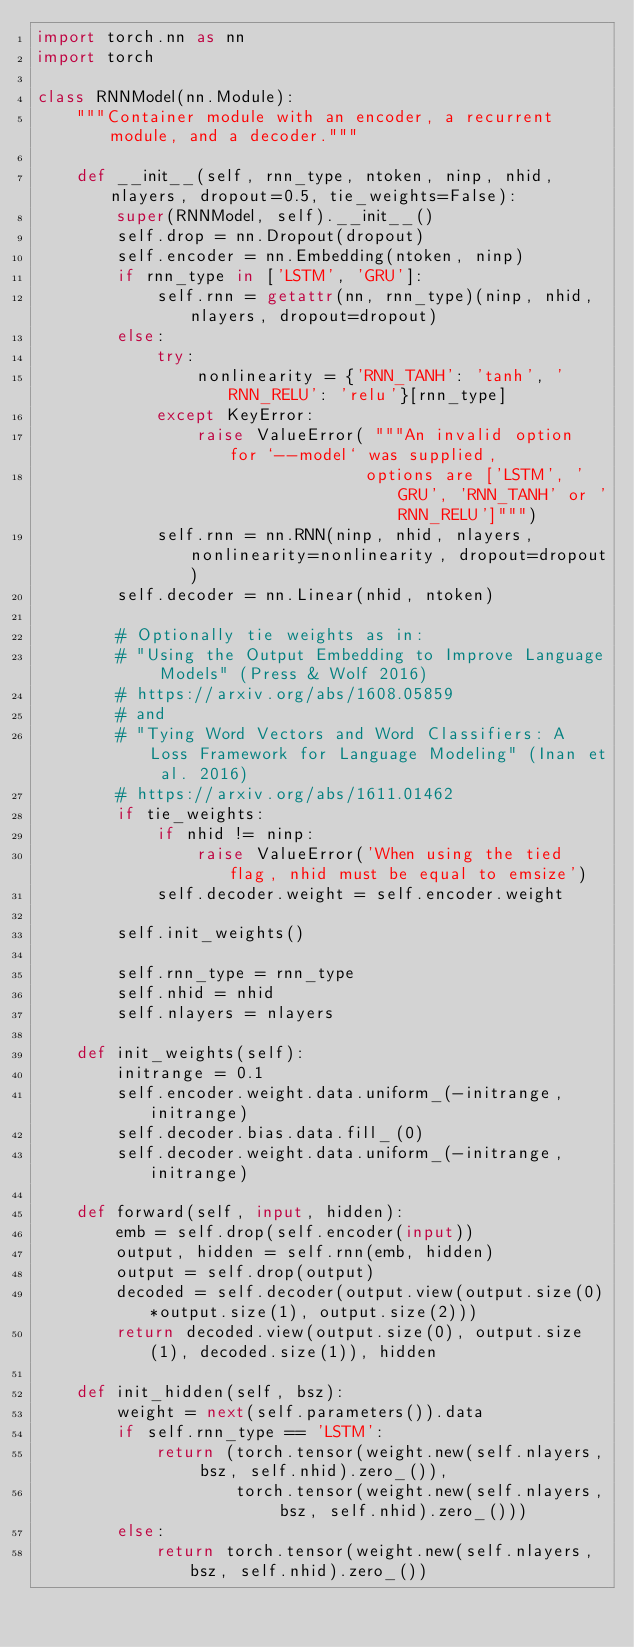Convert code to text. <code><loc_0><loc_0><loc_500><loc_500><_Python_>import torch.nn as nn
import torch

class RNNModel(nn.Module):
    """Container module with an encoder, a recurrent module, and a decoder."""

    def __init__(self, rnn_type, ntoken, ninp, nhid, nlayers, dropout=0.5, tie_weights=False):
        super(RNNModel, self).__init__()
        self.drop = nn.Dropout(dropout)
        self.encoder = nn.Embedding(ntoken, ninp)
        if rnn_type in ['LSTM', 'GRU']:
            self.rnn = getattr(nn, rnn_type)(ninp, nhid, nlayers, dropout=dropout)
        else:
            try:
                nonlinearity = {'RNN_TANH': 'tanh', 'RNN_RELU': 'relu'}[rnn_type]
            except KeyError:
                raise ValueError( """An invalid option for `--model` was supplied,
                                 options are ['LSTM', 'GRU', 'RNN_TANH' or 'RNN_RELU']""")
            self.rnn = nn.RNN(ninp, nhid, nlayers, nonlinearity=nonlinearity, dropout=dropout)
        self.decoder = nn.Linear(nhid, ntoken)

        # Optionally tie weights as in:
        # "Using the Output Embedding to Improve Language Models" (Press & Wolf 2016)
        # https://arxiv.org/abs/1608.05859
        # and
        # "Tying Word Vectors and Word Classifiers: A Loss Framework for Language Modeling" (Inan et al. 2016)
        # https://arxiv.org/abs/1611.01462
        if tie_weights:
            if nhid != ninp:
                raise ValueError('When using the tied flag, nhid must be equal to emsize')
            self.decoder.weight = self.encoder.weight

        self.init_weights()

        self.rnn_type = rnn_type
        self.nhid = nhid
        self.nlayers = nlayers

    def init_weights(self):
        initrange = 0.1
        self.encoder.weight.data.uniform_(-initrange, initrange)
        self.decoder.bias.data.fill_(0)
        self.decoder.weight.data.uniform_(-initrange, initrange)

    def forward(self, input, hidden):
        emb = self.drop(self.encoder(input))
        output, hidden = self.rnn(emb, hidden)
        output = self.drop(output)
        decoded = self.decoder(output.view(output.size(0)*output.size(1), output.size(2)))
        return decoded.view(output.size(0), output.size(1), decoded.size(1)), hidden

    def init_hidden(self, bsz):
        weight = next(self.parameters()).data
        if self.rnn_type == 'LSTM':
            return (torch.tensor(weight.new(self.nlayers, bsz, self.nhid).zero_()),
                    torch.tensor(weight.new(self.nlayers, bsz, self.nhid).zero_()))
        else:
            return torch.tensor(weight.new(self.nlayers, bsz, self.nhid).zero_())
</code> 